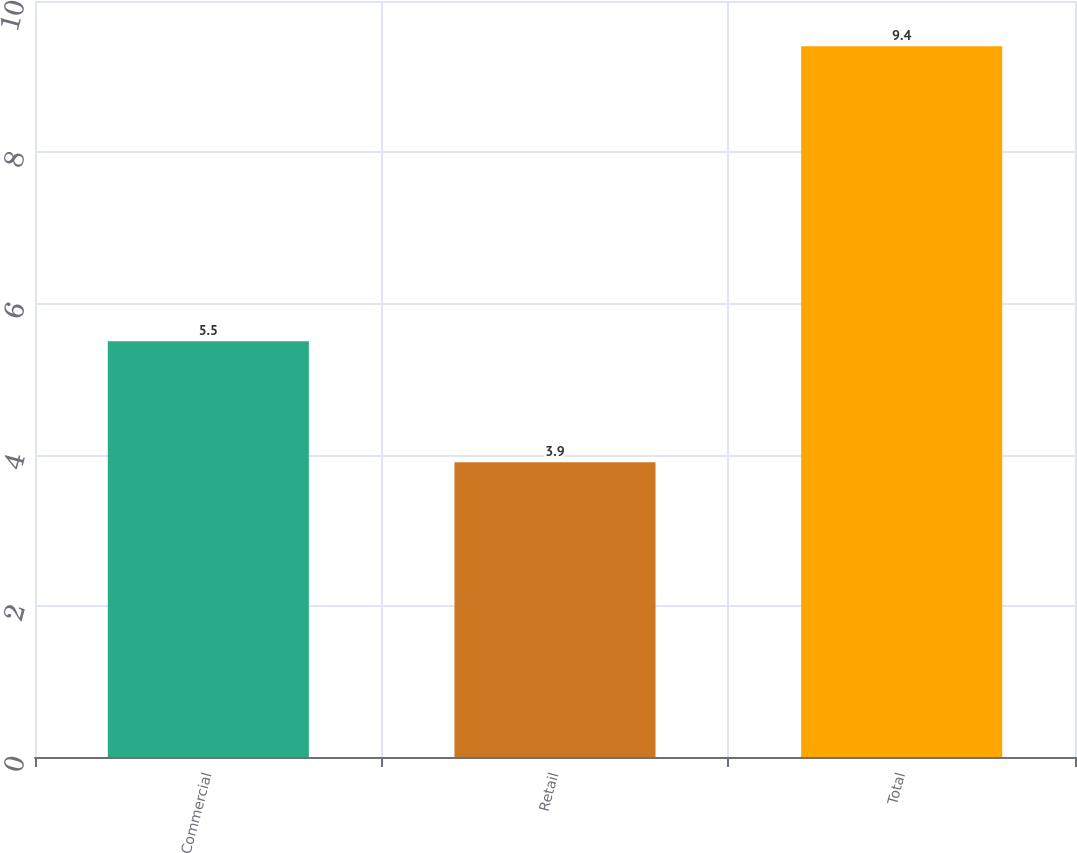Convert chart to OTSL. <chart><loc_0><loc_0><loc_500><loc_500><bar_chart><fcel>Commercial<fcel>Retail<fcel>Total<nl><fcel>5.5<fcel>3.9<fcel>9.4<nl></chart> 